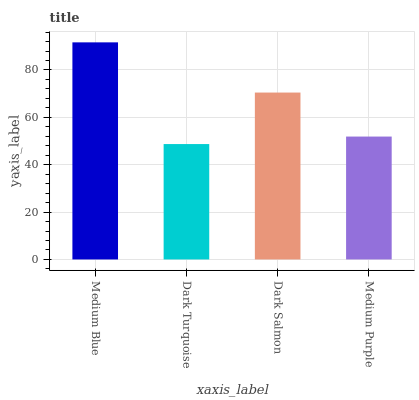Is Dark Turquoise the minimum?
Answer yes or no. Yes. Is Medium Blue the maximum?
Answer yes or no. Yes. Is Dark Salmon the minimum?
Answer yes or no. No. Is Dark Salmon the maximum?
Answer yes or no. No. Is Dark Salmon greater than Dark Turquoise?
Answer yes or no. Yes. Is Dark Turquoise less than Dark Salmon?
Answer yes or no. Yes. Is Dark Turquoise greater than Dark Salmon?
Answer yes or no. No. Is Dark Salmon less than Dark Turquoise?
Answer yes or no. No. Is Dark Salmon the high median?
Answer yes or no. Yes. Is Medium Purple the low median?
Answer yes or no. Yes. Is Medium Blue the high median?
Answer yes or no. No. Is Dark Turquoise the low median?
Answer yes or no. No. 